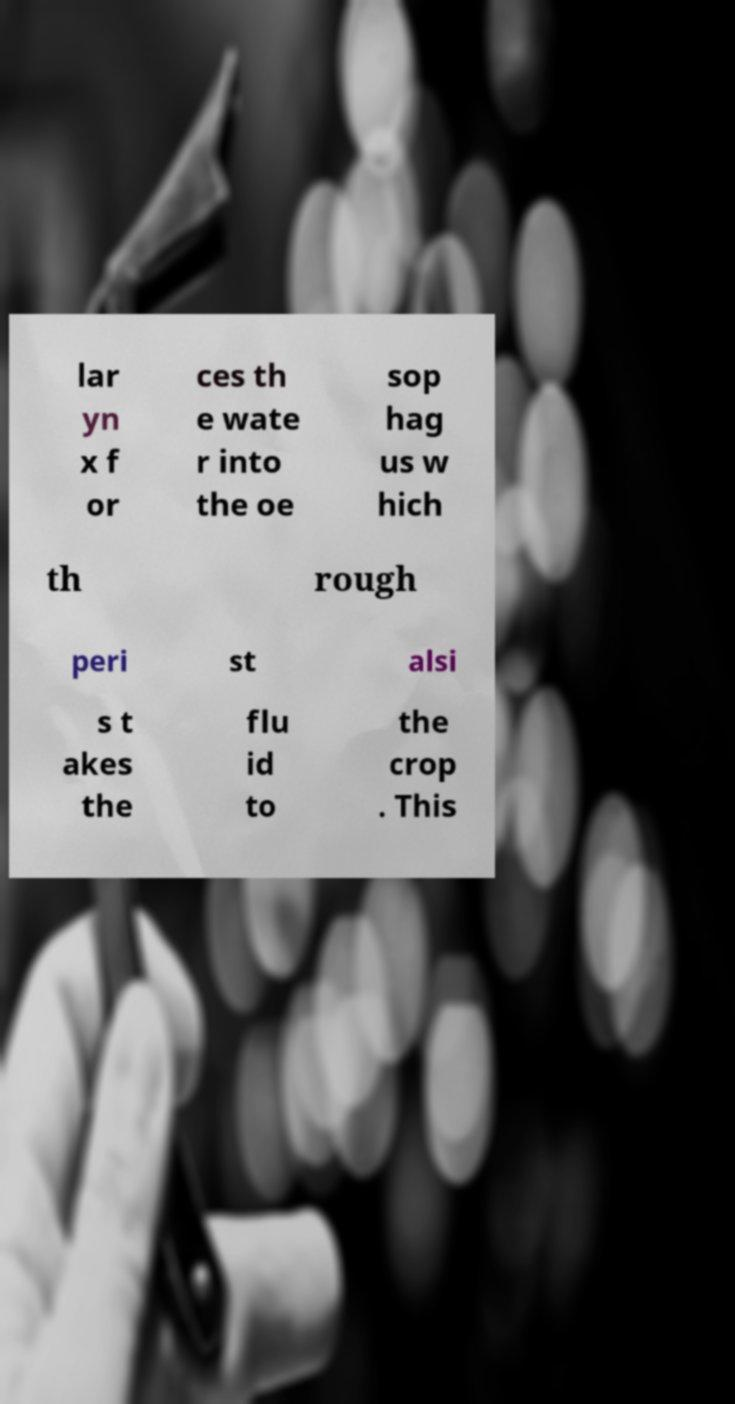Please identify and transcribe the text found in this image. lar yn x f or ces th e wate r into the oe sop hag us w hich th rough peri st alsi s t akes the flu id to the crop . This 